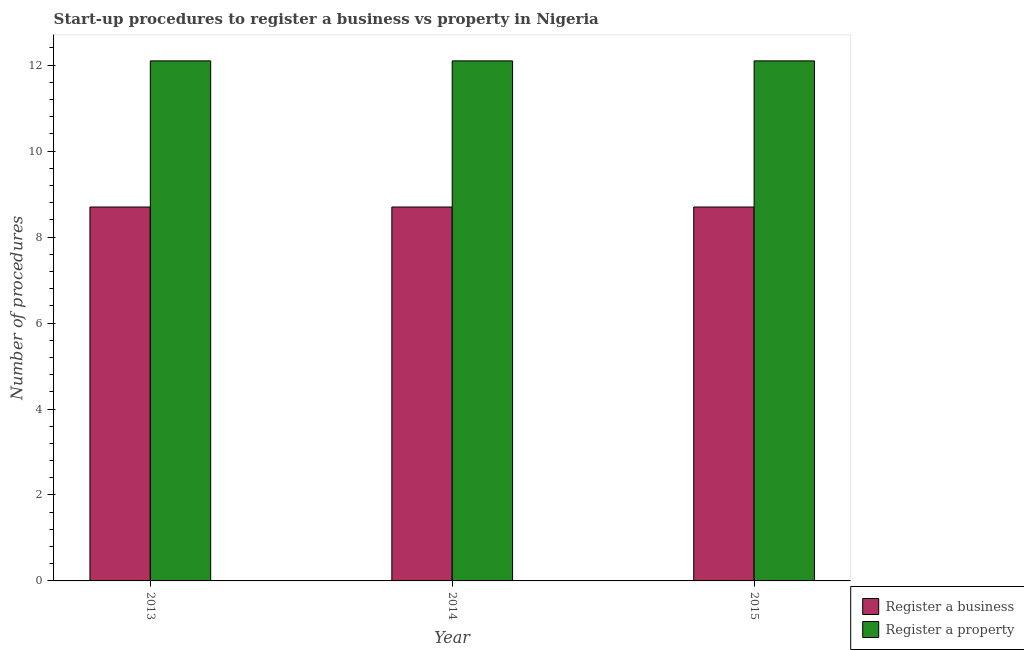How many different coloured bars are there?
Ensure brevity in your answer.  2. Are the number of bars per tick equal to the number of legend labels?
Provide a short and direct response. Yes. How many bars are there on the 2nd tick from the left?
Provide a succinct answer. 2. How many bars are there on the 3rd tick from the right?
Provide a short and direct response. 2. In which year was the number of procedures to register a business maximum?
Provide a short and direct response. 2013. In which year was the number of procedures to register a business minimum?
Provide a succinct answer. 2013. What is the total number of procedures to register a business in the graph?
Offer a terse response. 26.1. What is the difference between the number of procedures to register a business in 2014 and that in 2015?
Offer a very short reply. 0. In how many years, is the number of procedures to register a business greater than 2.4?
Your response must be concise. 3. Is the difference between the number of procedures to register a business in 2013 and 2014 greater than the difference between the number of procedures to register a property in 2013 and 2014?
Give a very brief answer. No. What is the difference between the highest and the lowest number of procedures to register a property?
Your response must be concise. 0. What does the 2nd bar from the left in 2013 represents?
Provide a short and direct response. Register a property. What does the 1st bar from the right in 2015 represents?
Provide a short and direct response. Register a property. How many bars are there?
Offer a terse response. 6. Are all the bars in the graph horizontal?
Make the answer very short. No. How many years are there in the graph?
Give a very brief answer. 3. Are the values on the major ticks of Y-axis written in scientific E-notation?
Give a very brief answer. No. Does the graph contain any zero values?
Keep it short and to the point. No. Does the graph contain grids?
Your response must be concise. No. How many legend labels are there?
Offer a very short reply. 2. How are the legend labels stacked?
Your answer should be very brief. Vertical. What is the title of the graph?
Make the answer very short. Start-up procedures to register a business vs property in Nigeria. What is the label or title of the Y-axis?
Give a very brief answer. Number of procedures. What is the Number of procedures of Register a business in 2013?
Your answer should be very brief. 8.7. What is the Number of procedures in Register a business in 2014?
Make the answer very short. 8.7. What is the Number of procedures in Register a property in 2014?
Your answer should be compact. 12.1. What is the Number of procedures in Register a business in 2015?
Give a very brief answer. 8.7. What is the Number of procedures of Register a property in 2015?
Provide a succinct answer. 12.1. Across all years, what is the maximum Number of procedures in Register a business?
Your answer should be compact. 8.7. Across all years, what is the minimum Number of procedures of Register a property?
Your response must be concise. 12.1. What is the total Number of procedures of Register a business in the graph?
Give a very brief answer. 26.1. What is the total Number of procedures in Register a property in the graph?
Provide a succinct answer. 36.3. What is the difference between the Number of procedures in Register a property in 2013 and that in 2014?
Offer a terse response. 0. What is the difference between the Number of procedures of Register a business in 2013 and the Number of procedures of Register a property in 2015?
Your response must be concise. -3.4. In the year 2014, what is the difference between the Number of procedures of Register a business and Number of procedures of Register a property?
Keep it short and to the point. -3.4. In the year 2015, what is the difference between the Number of procedures in Register a business and Number of procedures in Register a property?
Keep it short and to the point. -3.4. What is the ratio of the Number of procedures in Register a business in 2013 to that in 2014?
Your response must be concise. 1. What is the ratio of the Number of procedures of Register a business in 2014 to that in 2015?
Your answer should be compact. 1. What is the difference between the highest and the second highest Number of procedures of Register a property?
Your answer should be very brief. 0. What is the difference between the highest and the lowest Number of procedures of Register a property?
Your response must be concise. 0. 